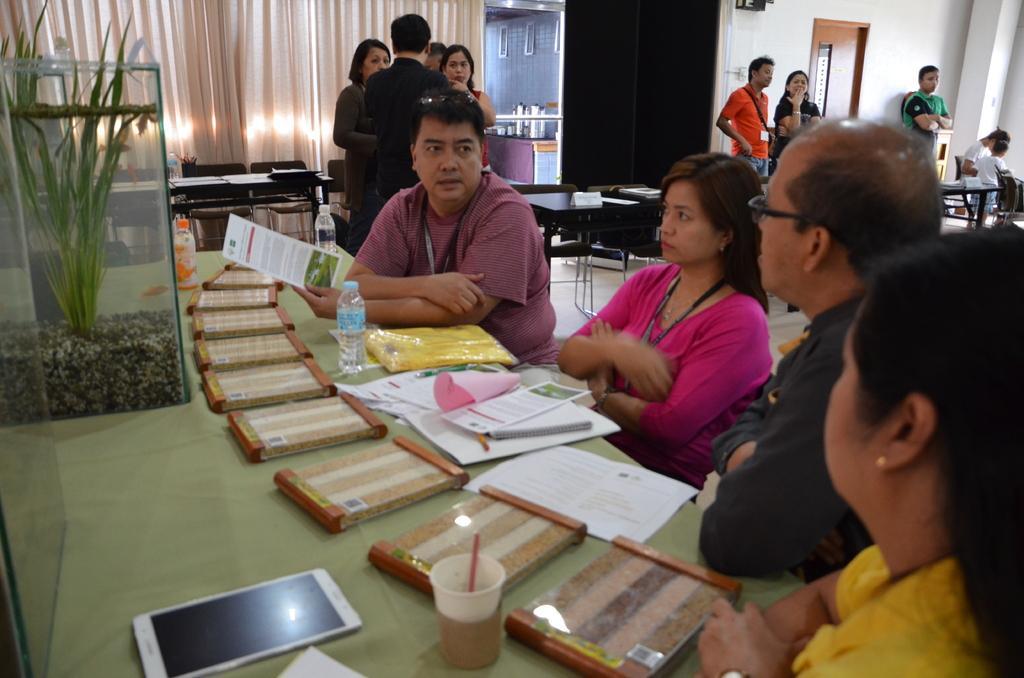Please provide a concise description of this image. As we can see in the image, there are some people. Few of them are sitting and few of them are standing and there is a table over here. On table there is a mobile phone, paper, books, bottle and a glass and on the left side there is a plant and there are cream colored curtains. 